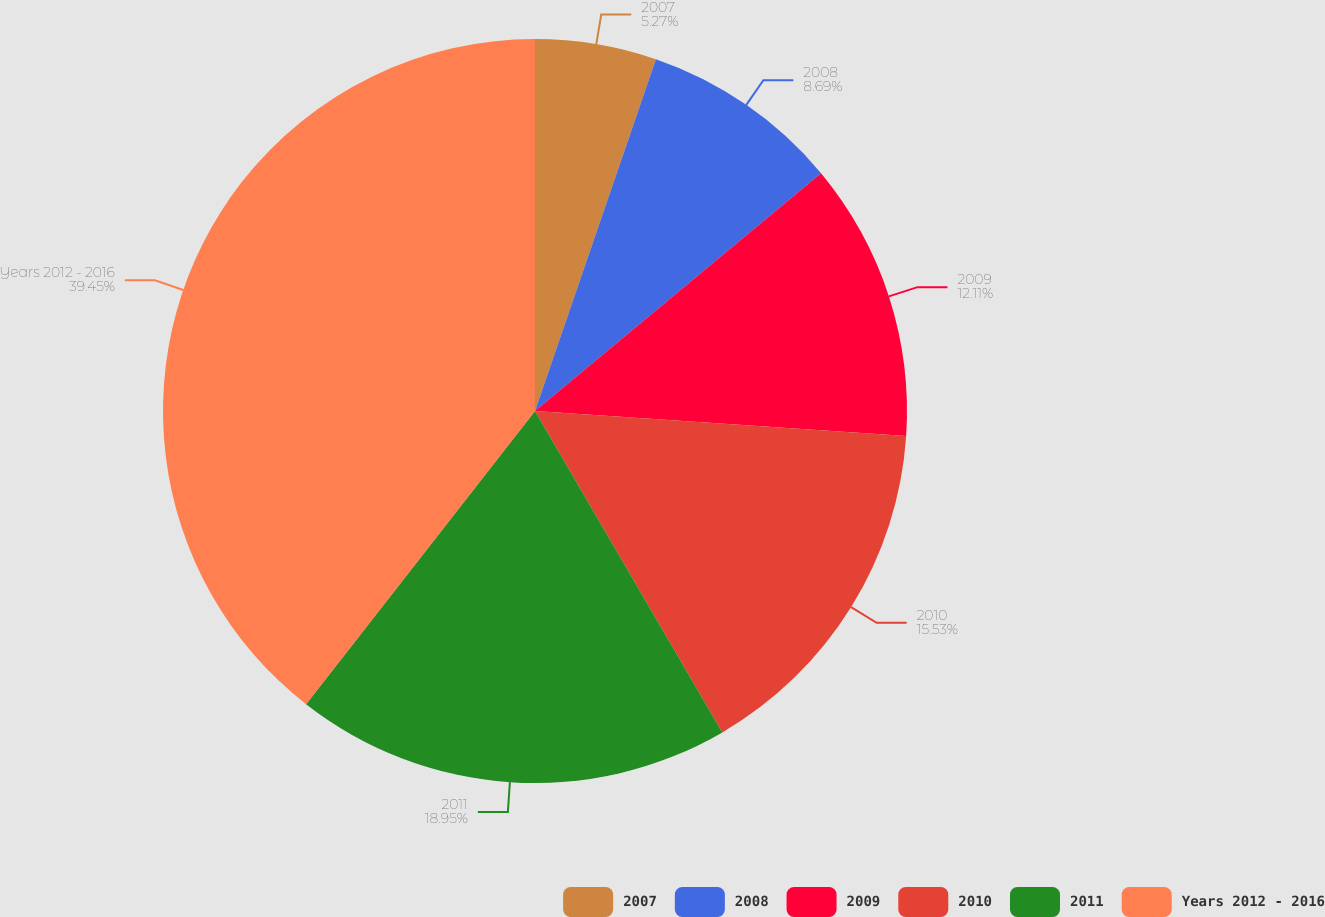Convert chart. <chart><loc_0><loc_0><loc_500><loc_500><pie_chart><fcel>2007<fcel>2008<fcel>2009<fcel>2010<fcel>2011<fcel>Years 2012 - 2016<nl><fcel>5.27%<fcel>8.69%<fcel>12.11%<fcel>15.53%<fcel>18.95%<fcel>39.45%<nl></chart> 